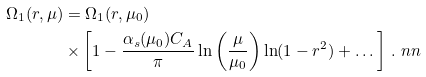Convert formula to latex. <formula><loc_0><loc_0><loc_500><loc_500>\Omega _ { 1 } ( r , \mu ) & = \Omega _ { 1 } ( r , \mu _ { 0 } ) \\ & \times \left [ 1 - \frac { \alpha _ { s } ( \mu _ { 0 } ) C _ { A } } { \pi } \ln \left ( \frac { \mu } { \mu _ { 0 } } \right ) \ln ( 1 - r ^ { 2 } ) + \dots \right ] \, . \ n n</formula> 